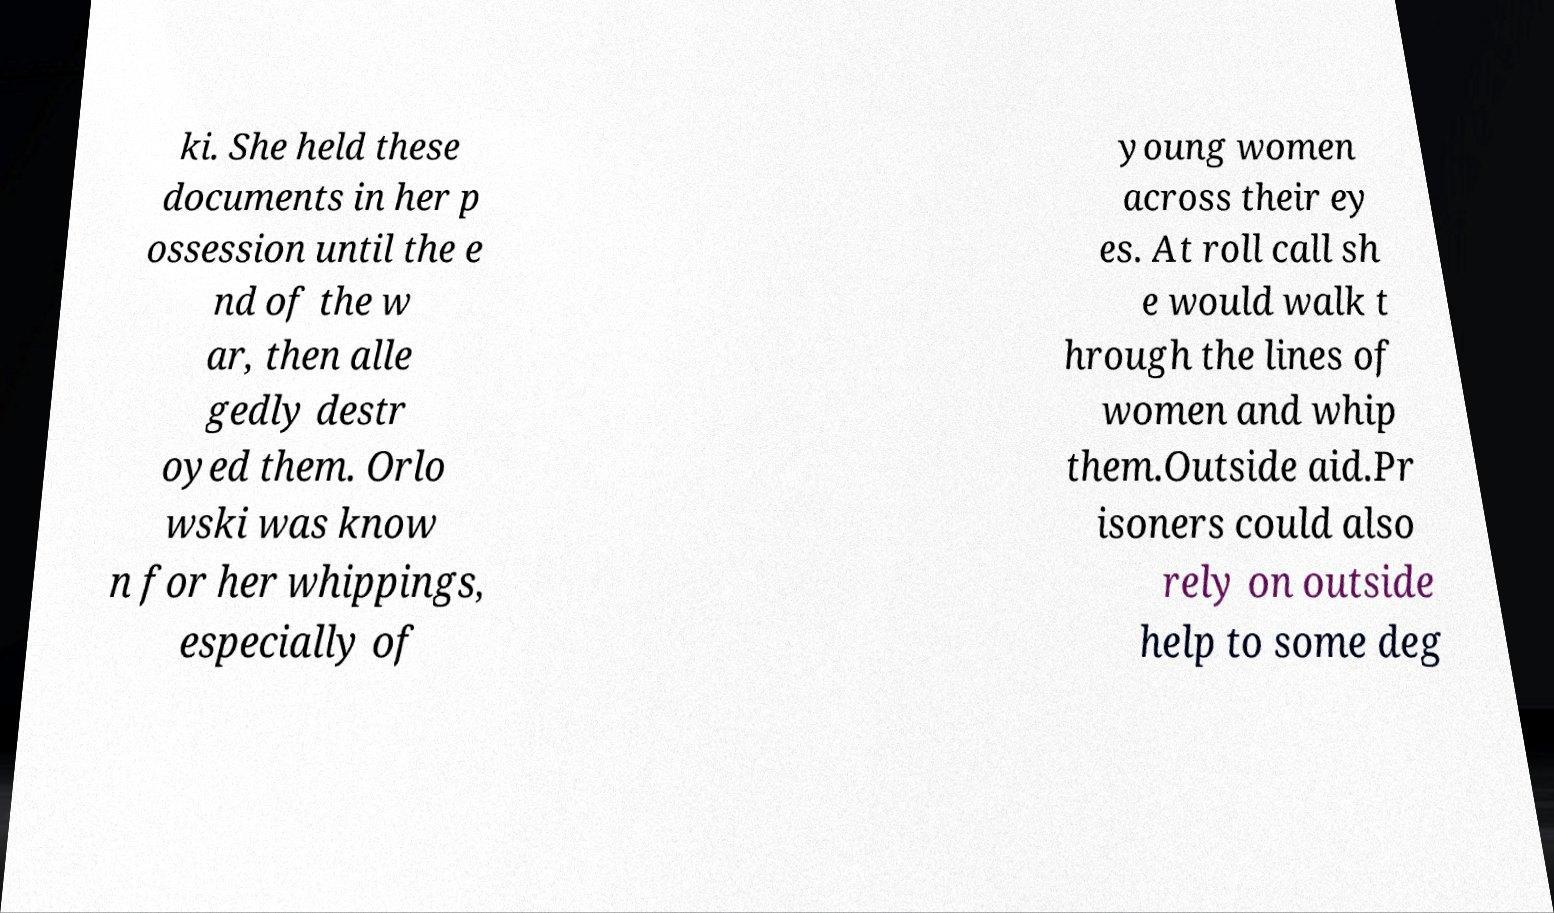I need the written content from this picture converted into text. Can you do that? ki. She held these documents in her p ossession until the e nd of the w ar, then alle gedly destr oyed them. Orlo wski was know n for her whippings, especially of young women across their ey es. At roll call sh e would walk t hrough the lines of women and whip them.Outside aid.Pr isoners could also rely on outside help to some deg 